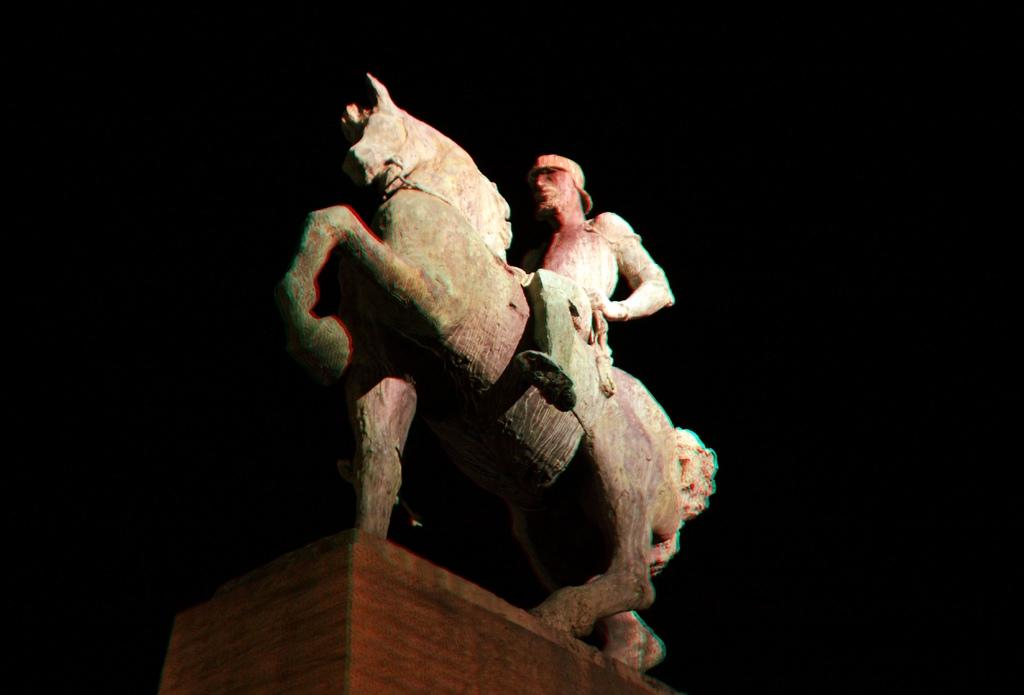What type of statues are present in the image? There is a horse statue and a person statue in the image. What can be observed about the background of the image? The background of the image is dark. How many people are in the crowd in the image? There is no crowd present in the image; it only features the horse statue and the person statue. What is the condition of the bedroom in the image? There is no bedroom present in the image. 